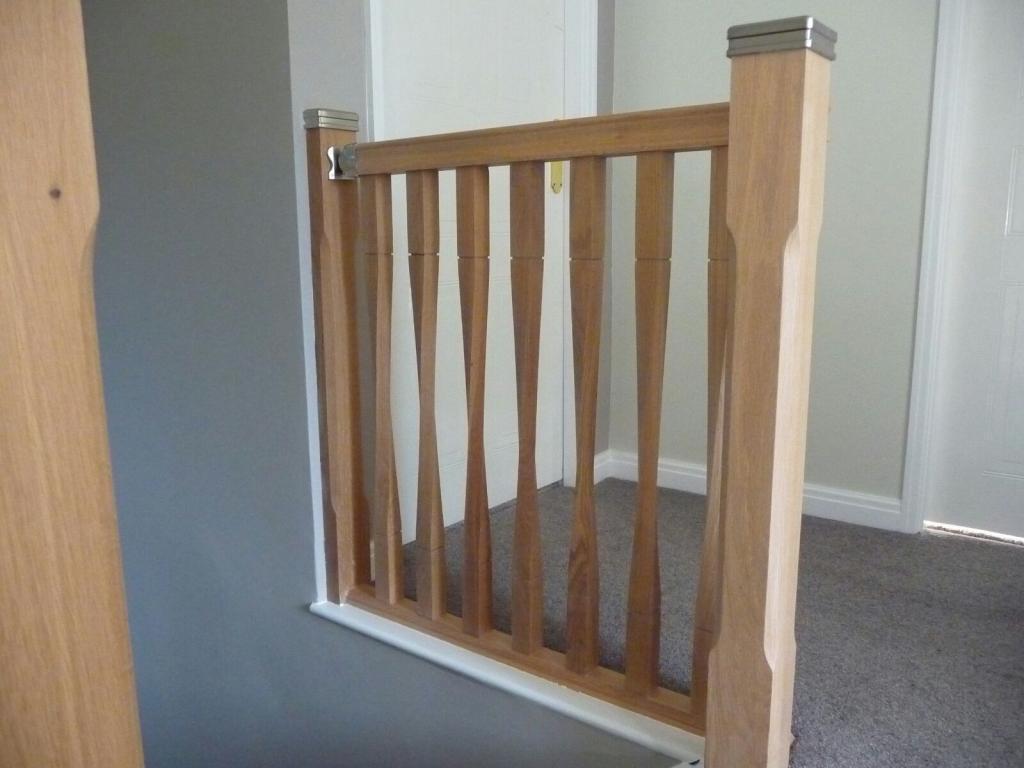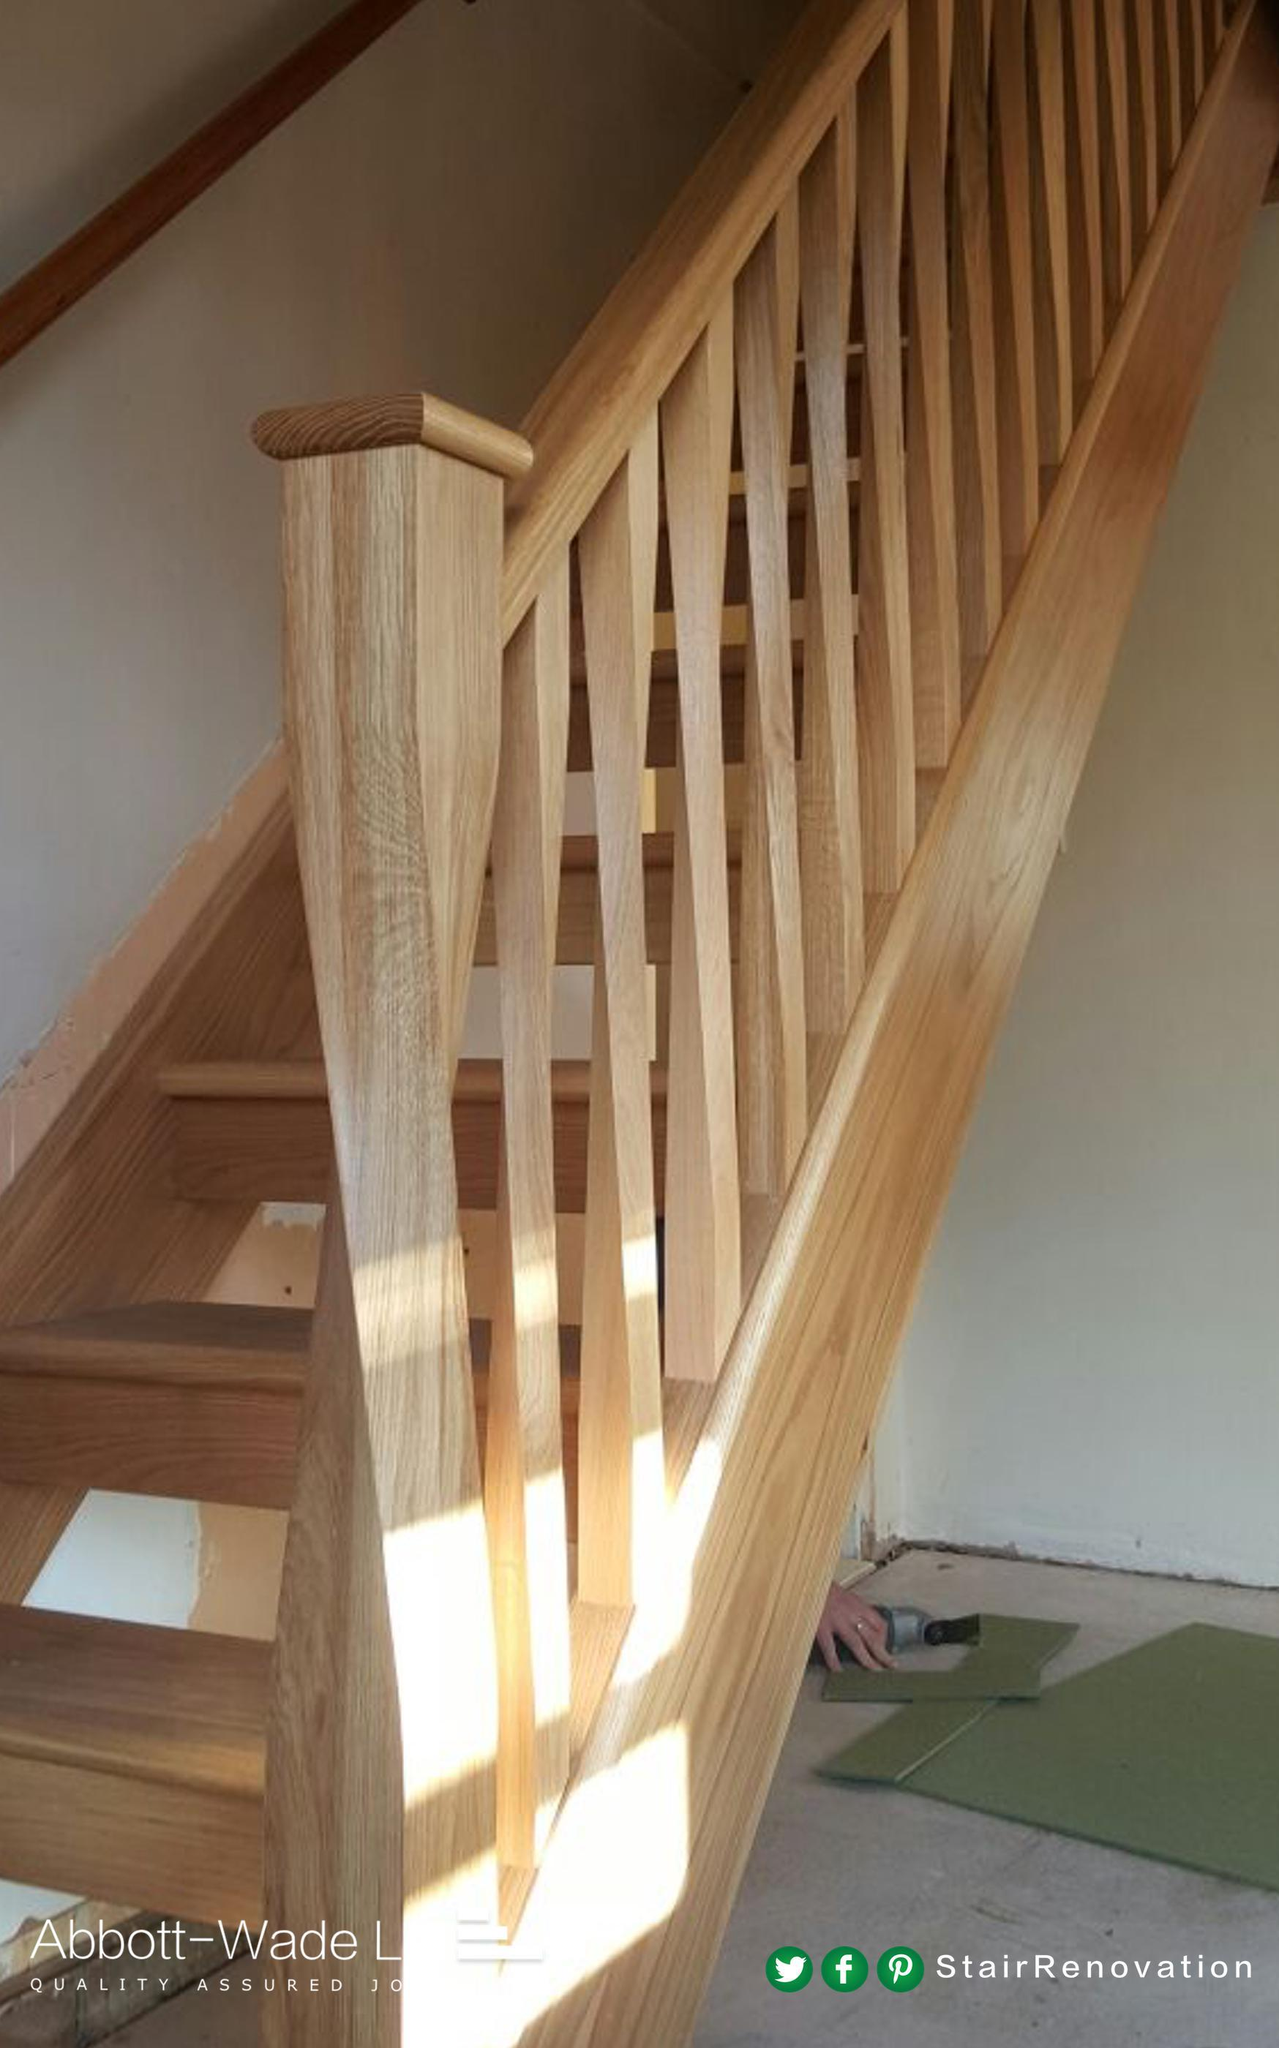The first image is the image on the left, the second image is the image on the right. Assess this claim about the two images: "One image shows a wooden stair baluster with a silver cap, and vertical rails of twisted wood in front of gray carpeting.". Correct or not? Answer yes or no. Yes. The first image is the image on the left, the second image is the image on the right. For the images shown, is this caption "In one of the images, the stairway post is made of wood and metal." true? Answer yes or no. Yes. 